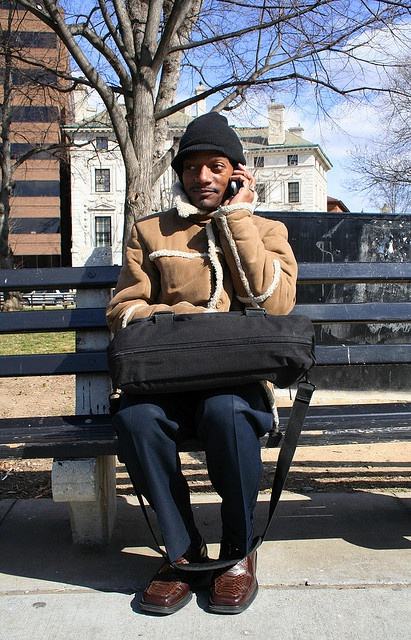Describe the objects in this image and their specific colors. I can see people in black, gray, and tan tones, bench in black, gray, and darkblue tones, handbag in black, gray, and beige tones, and cell phone in black, gray, white, and navy tones in this image. 